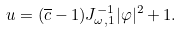<formula> <loc_0><loc_0><loc_500><loc_500>u = ( \overline { c } - 1 ) J _ { \omega , 1 } ^ { - 1 } | \varphi | ^ { 2 } + 1 .</formula> 